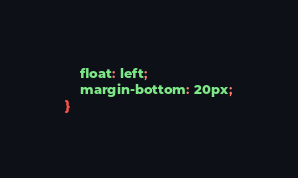Convert code to text. <code><loc_0><loc_0><loc_500><loc_500><_CSS_>    float: left;
    margin-bottom: 20px;
}</code> 